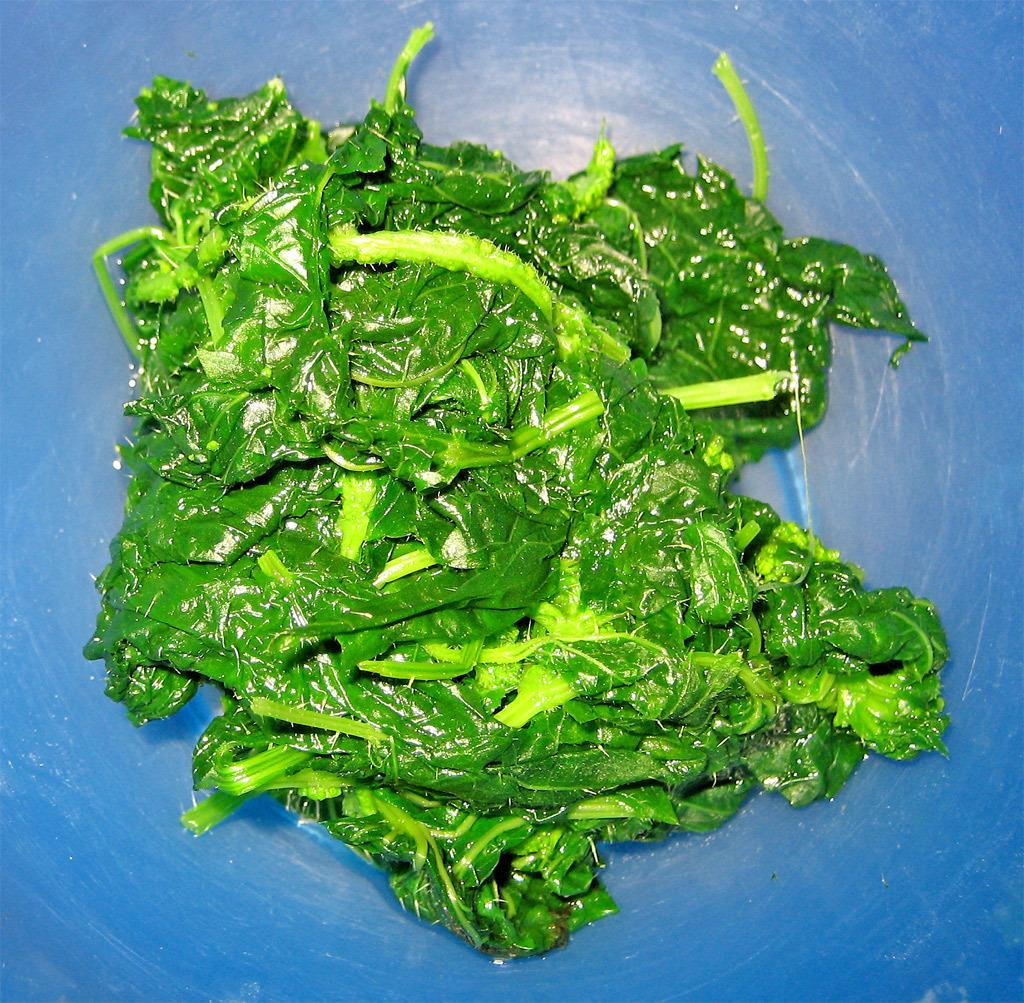What type of vegetable is present in the image? There is a green leafy vegetable in the image. What color is the background of the image? The background of the image is blue. What type of powder is being added to the vegetable in the image? There is no powder being added to the vegetable in the image; it is a static image of a green leafy vegetable against a blue background. 